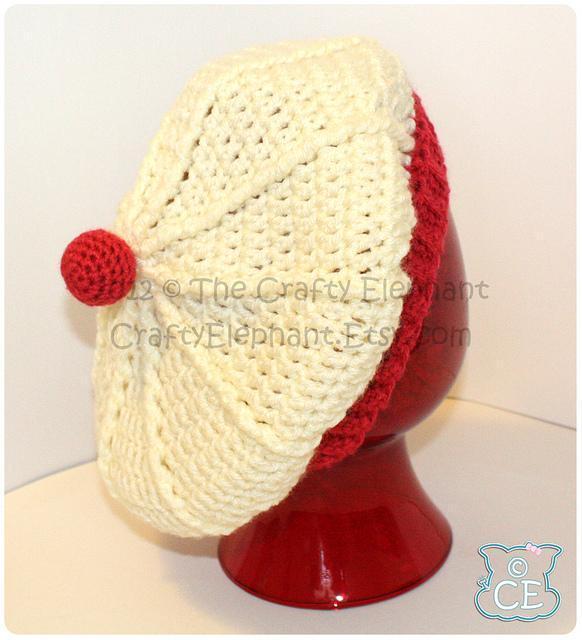How many people are in the picture?
Give a very brief answer. 0. 